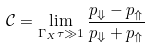Convert formula to latex. <formula><loc_0><loc_0><loc_500><loc_500>\mathcal { C } = \lim _ { \Gamma _ { X } \tau \gg 1 } \frac { p _ { \Downarrow } - p _ { \Uparrow } } { p _ { \Downarrow } + p _ { \Uparrow } }</formula> 